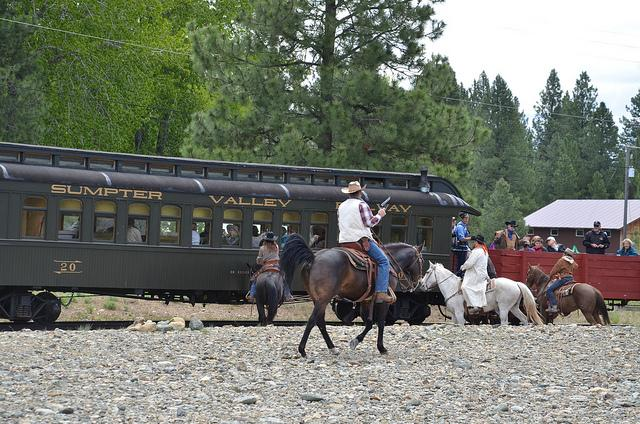What are the men on horses dressed as? Please explain your reasoning. cowboys. They are dressed up like cowboys. 